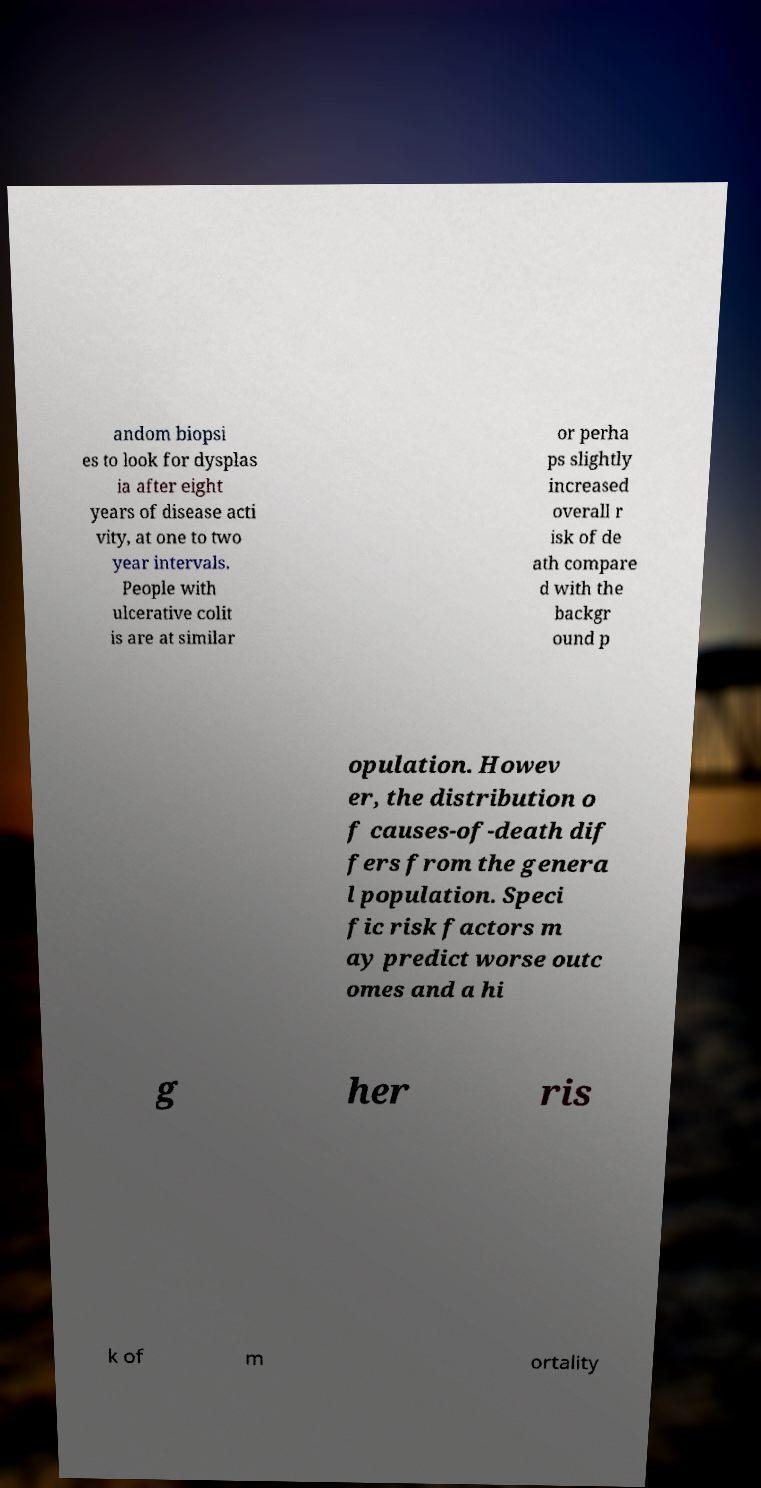Can you accurately transcribe the text from the provided image for me? andom biopsi es to look for dysplas ia after eight years of disease acti vity, at one to two year intervals. People with ulcerative colit is are at similar or perha ps slightly increased overall r isk of de ath compare d with the backgr ound p opulation. Howev er, the distribution o f causes-of-death dif fers from the genera l population. Speci fic risk factors m ay predict worse outc omes and a hi g her ris k of m ortality 